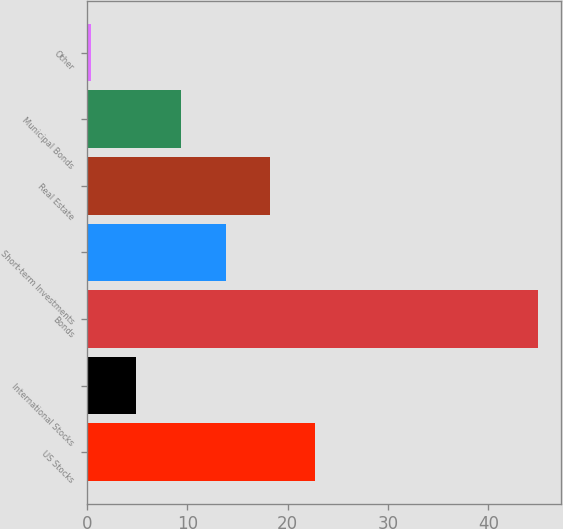Convert chart. <chart><loc_0><loc_0><loc_500><loc_500><bar_chart><fcel>US Stocks<fcel>International Stocks<fcel>Bonds<fcel>Short-term Investments<fcel>Real Estate<fcel>Municipal Bonds<fcel>Other<nl><fcel>22.74<fcel>4.9<fcel>45<fcel>13.82<fcel>18.28<fcel>9.36<fcel>0.44<nl></chart> 